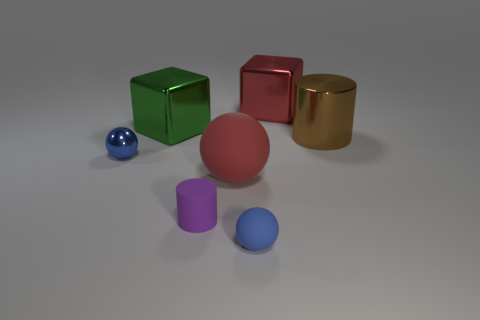What could be the purpose of these objects? These objects could serve as models for a 3D rendering tutorial, focusing on teaching about shapes, lighting, and material properties in a virtual environment. They're perfect for helping artists understand nuances in reflections and textures. 